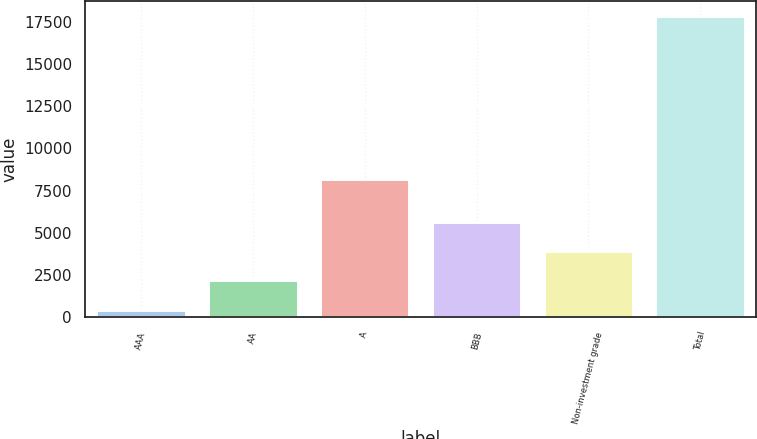Convert chart. <chart><loc_0><loc_0><loc_500><loc_500><bar_chart><fcel>AAA<fcel>AA<fcel>A<fcel>BBB<fcel>Non-investment grade<fcel>Total<nl><fcel>453<fcel>2191.7<fcel>8191<fcel>5669.1<fcel>3930.4<fcel>17840<nl></chart> 